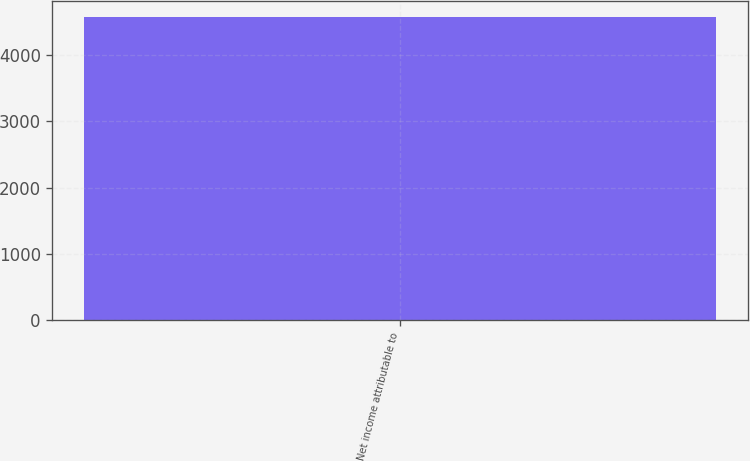Convert chart to OTSL. <chart><loc_0><loc_0><loc_500><loc_500><bar_chart><fcel>Net income attributable to<nl><fcel>4584<nl></chart> 